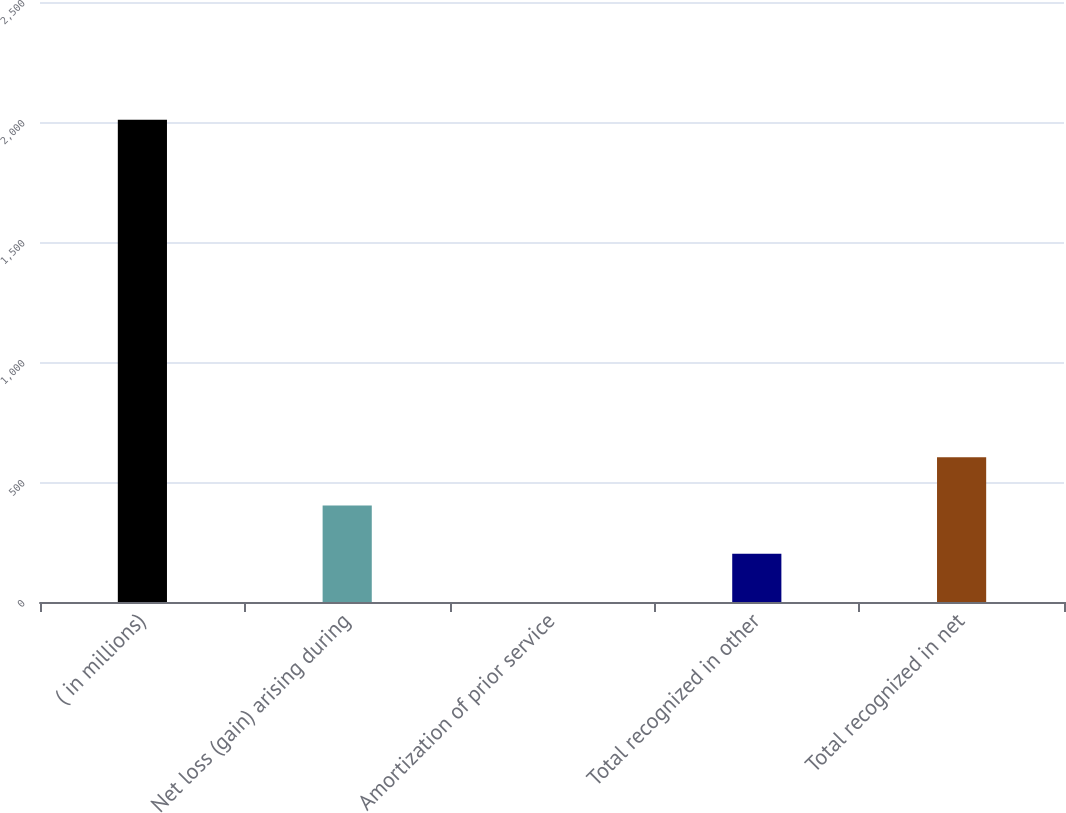<chart> <loc_0><loc_0><loc_500><loc_500><bar_chart><fcel>( in millions)<fcel>Net loss (gain) arising during<fcel>Amortization of prior service<fcel>Total recognized in other<fcel>Total recognized in net<nl><fcel>2009<fcel>401.88<fcel>0.1<fcel>200.99<fcel>602.77<nl></chart> 